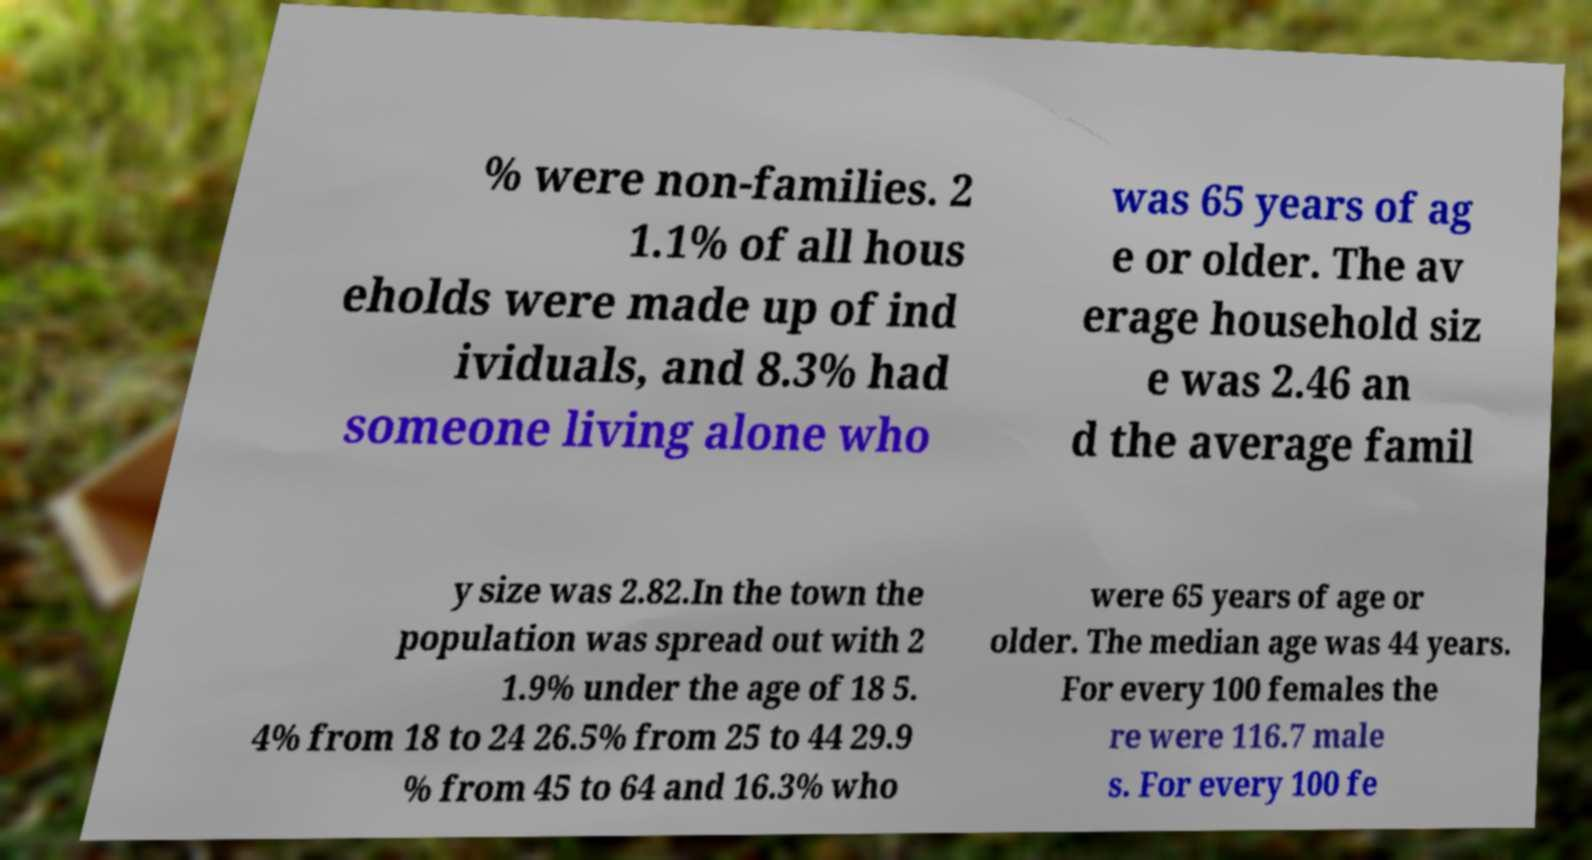There's text embedded in this image that I need extracted. Can you transcribe it verbatim? % were non-families. 2 1.1% of all hous eholds were made up of ind ividuals, and 8.3% had someone living alone who was 65 years of ag e or older. The av erage household siz e was 2.46 an d the average famil y size was 2.82.In the town the population was spread out with 2 1.9% under the age of 18 5. 4% from 18 to 24 26.5% from 25 to 44 29.9 % from 45 to 64 and 16.3% who were 65 years of age or older. The median age was 44 years. For every 100 females the re were 116.7 male s. For every 100 fe 